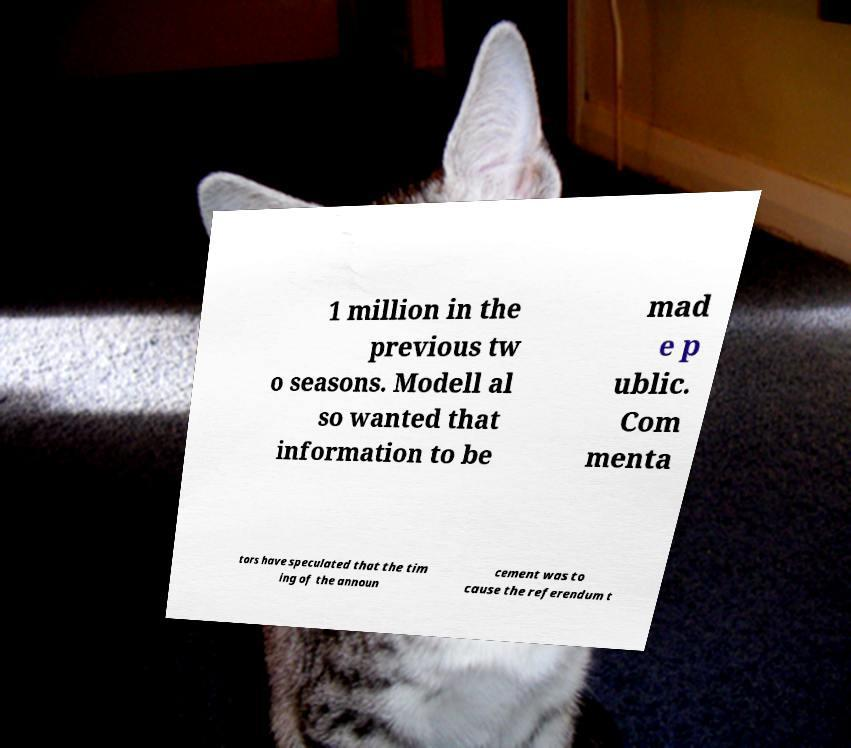Could you assist in decoding the text presented in this image and type it out clearly? 1 million in the previous tw o seasons. Modell al so wanted that information to be mad e p ublic. Com menta tors have speculated that the tim ing of the announ cement was to cause the referendum t 